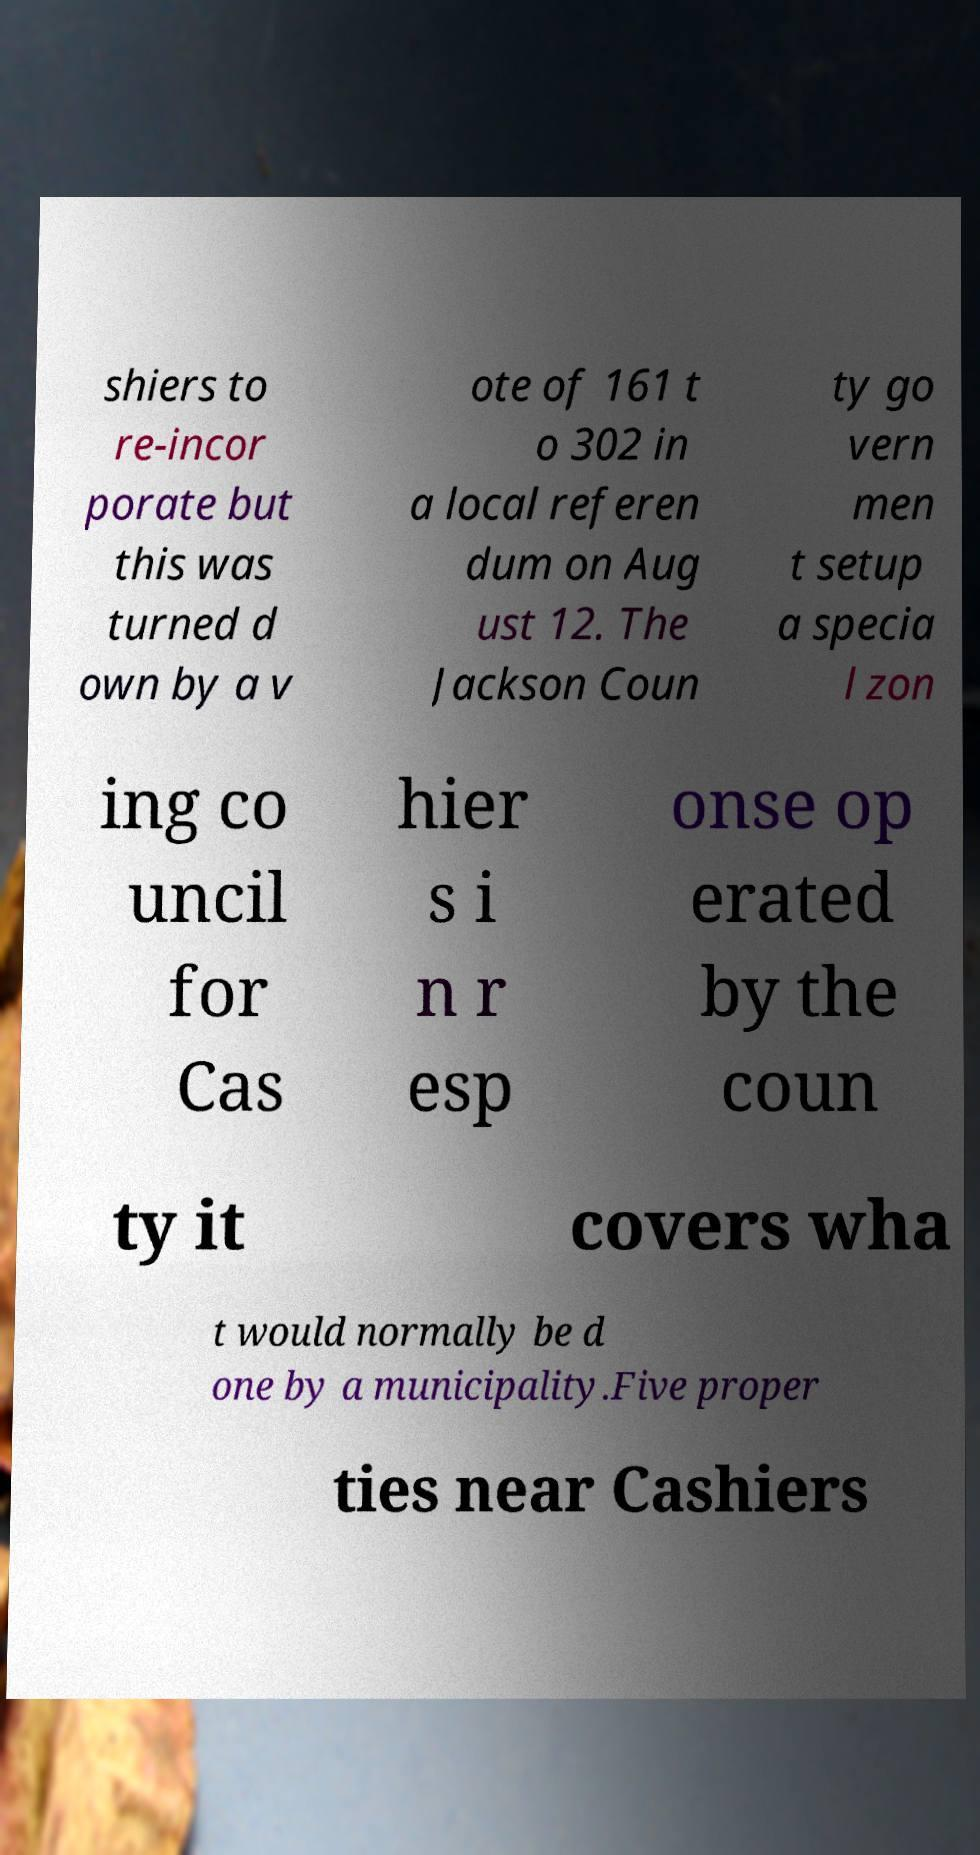What messages or text are displayed in this image? I need them in a readable, typed format. shiers to re-incor porate but this was turned d own by a v ote of 161 t o 302 in a local referen dum on Aug ust 12. The Jackson Coun ty go vern men t setup a specia l zon ing co uncil for Cas hier s i n r esp onse op erated by the coun ty it covers wha t would normally be d one by a municipality.Five proper ties near Cashiers 